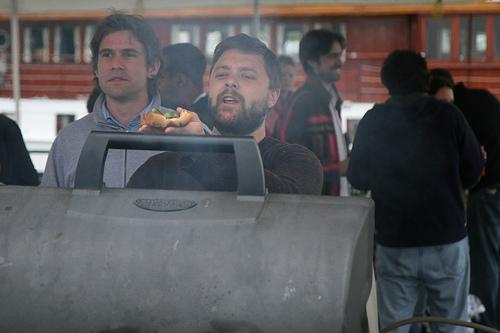What is the man holding in his hand? The man is holding a sandwich or a bun in his hand. Does the grill in the image appear to be cooking any food at the moment? Yes, the grill is cooking food. Mention a notable architectural feature in the image. A red side of a building can be seen in the image. What is the color and style of the shirt worn by the man with a brown beard? The man with the brown beard is wearing a red plaid shirt. What type of facial hair does the man with the dark beard have? The man with the dark beard has a brown beard and mustache. Provide a brief description of the scene in the image. A group of men are socializing and cooking outside under a shelter near a building, using a dark gray metal grill. Are the men in the image participating in an indoor or outdoor activity? The men are participating in an outdoor activity. How many people in the image have brown hair? There are three people in the image who have brown hair. Identify the activity that the men in the image are participating in. The men in the image are socializing and cooking with a grill. Describe the appearance of the man with a brown mustache. The man with the brown mustache has short hair, brown facial hair, and is wearing a dark sweater. 